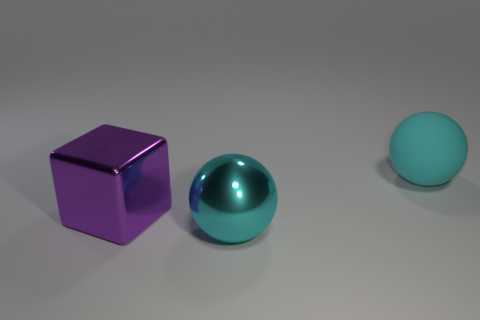Add 3 big cyan matte balls. How many objects exist? 6 Subtract all cubes. How many objects are left? 2 Add 1 small gray matte cylinders. How many small gray matte cylinders exist? 1 Subtract 0 brown cylinders. How many objects are left? 3 Subtract all large rubber spheres. Subtract all big cyan rubber balls. How many objects are left? 1 Add 1 large blocks. How many large blocks are left? 2 